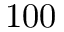Convert formula to latex. <formula><loc_0><loc_0><loc_500><loc_500>1 0 0</formula> 